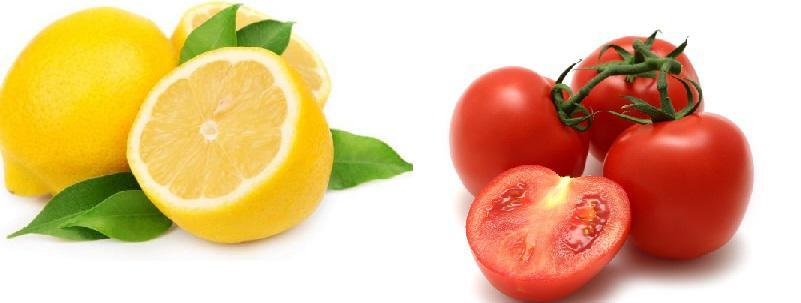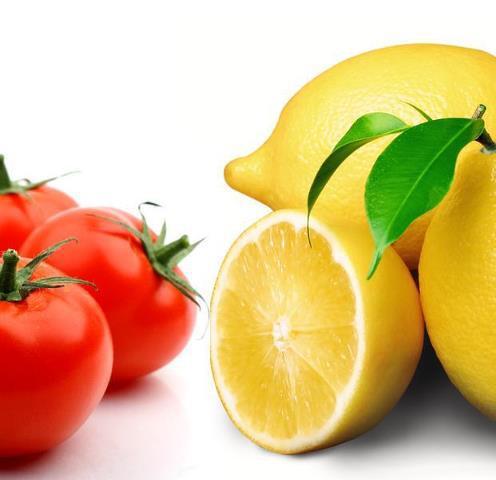The first image is the image on the left, the second image is the image on the right. Evaluate the accuracy of this statement regarding the images: "One image includes a non-jar type glass containing reddish-orange liquid, along with a whole tomato and a whole lemon.". Is it true? Answer yes or no. No. The first image is the image on the left, the second image is the image on the right. Considering the images on both sides, is "One of the images features a glass of tomato juice." valid? Answer yes or no. No. 